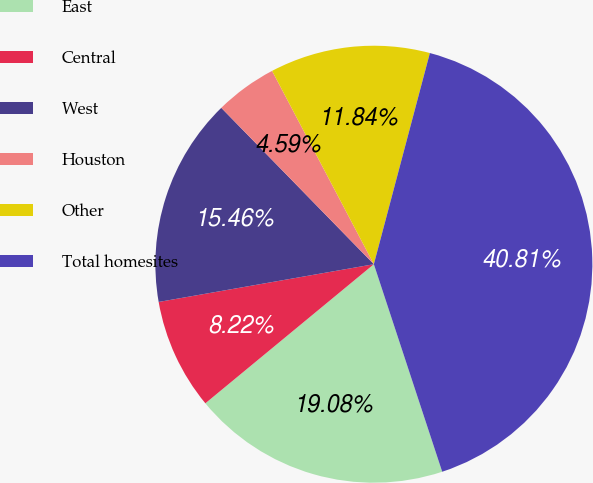Convert chart to OTSL. <chart><loc_0><loc_0><loc_500><loc_500><pie_chart><fcel>East<fcel>Central<fcel>West<fcel>Houston<fcel>Other<fcel>Total homesites<nl><fcel>19.08%<fcel>8.22%<fcel>15.46%<fcel>4.59%<fcel>11.84%<fcel>40.81%<nl></chart> 